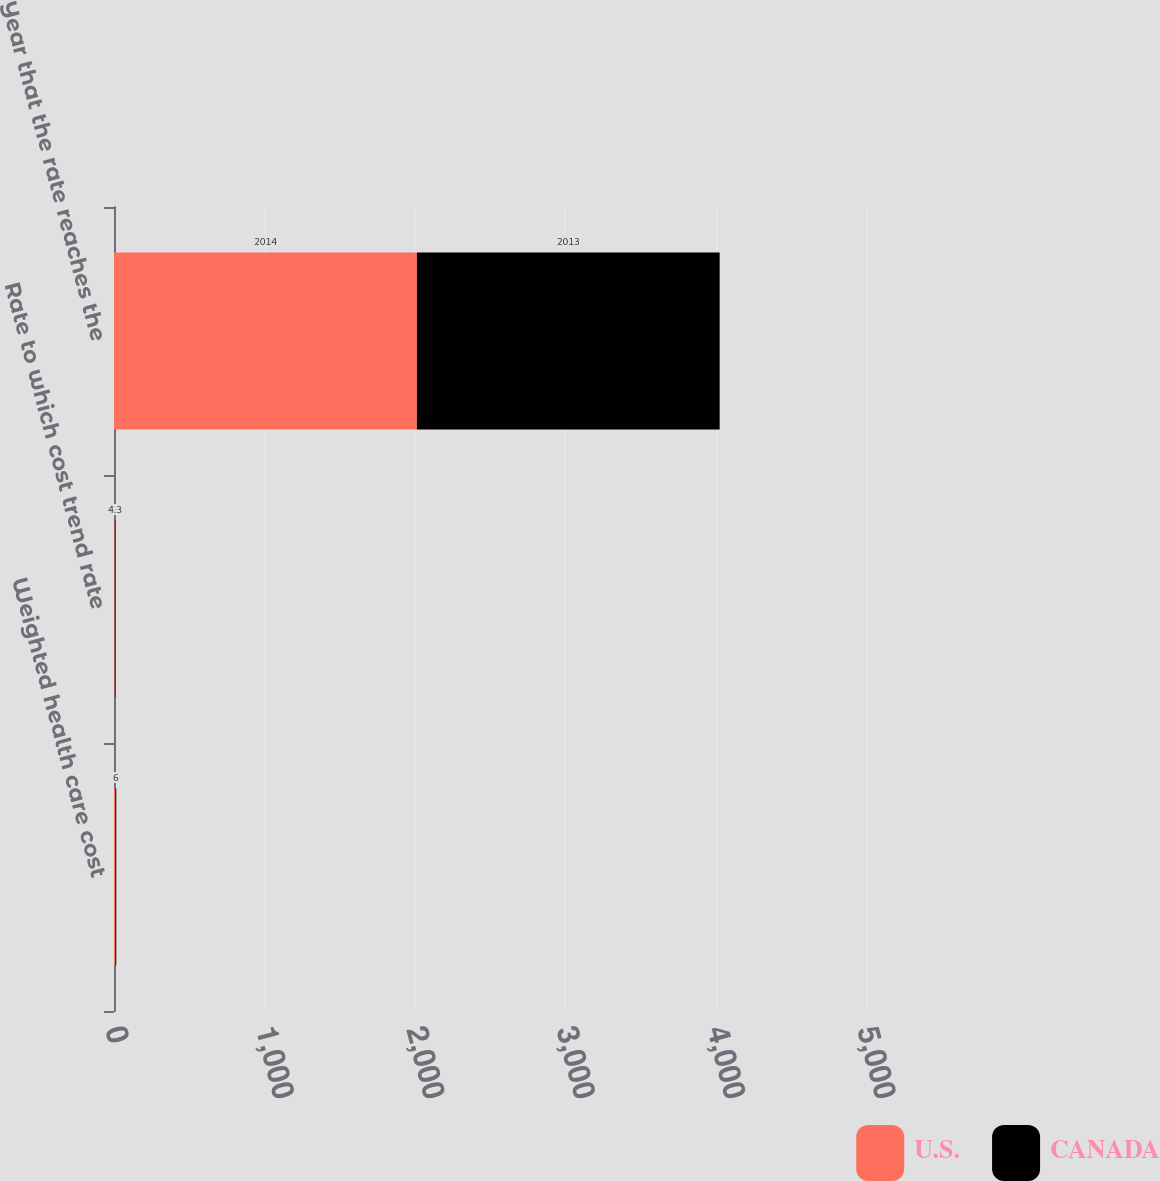<chart> <loc_0><loc_0><loc_500><loc_500><stacked_bar_chart><ecel><fcel>Weighted health care cost<fcel>Rate to which cost trend rate<fcel>Year that the rate reaches the<nl><fcel>U.S.<fcel>9<fcel>5<fcel>2014<nl><fcel>CANADA<fcel>6<fcel>4.3<fcel>2013<nl></chart> 